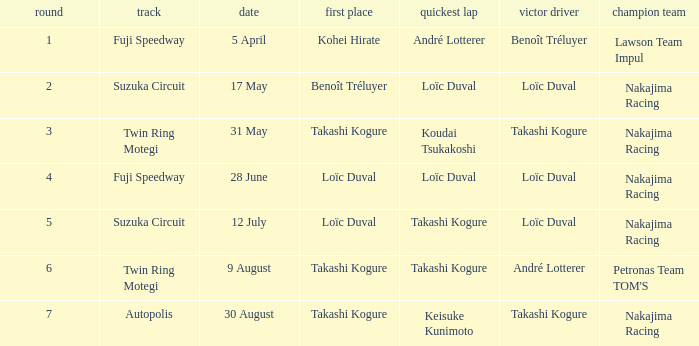Who was the driver for the winning team Lawson Team Impul? Benoît Tréluyer. 